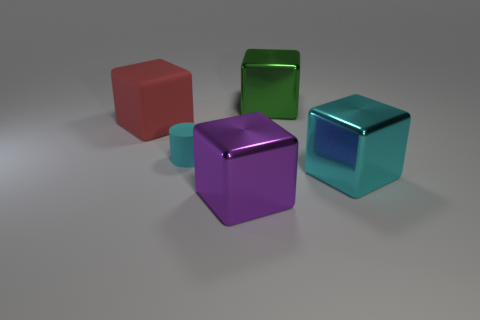Is the number of cyan blocks that are on the left side of the green metallic object less than the number of green blocks?
Make the answer very short. Yes. Are there any red shiny objects?
Offer a very short reply. No. What is the color of the matte thing that is the same shape as the purple metallic object?
Give a very brief answer. Red. Do the large object that is to the left of the purple shiny cube and the small object have the same color?
Your response must be concise. No. Does the green thing have the same size as the matte cube?
Give a very brief answer. Yes. What is the shape of the red thing that is made of the same material as the cylinder?
Provide a short and direct response. Cube. How many other things are the same shape as the purple thing?
Your answer should be very brief. 3. The matte object on the right side of the rubber object that is on the left side of the cyan object left of the green shiny block is what shape?
Provide a succinct answer. Cylinder. How many spheres are cyan things or big green objects?
Provide a short and direct response. 0. There is a big red cube to the left of the purple shiny object; is there a small matte cylinder to the left of it?
Your answer should be compact. No. 